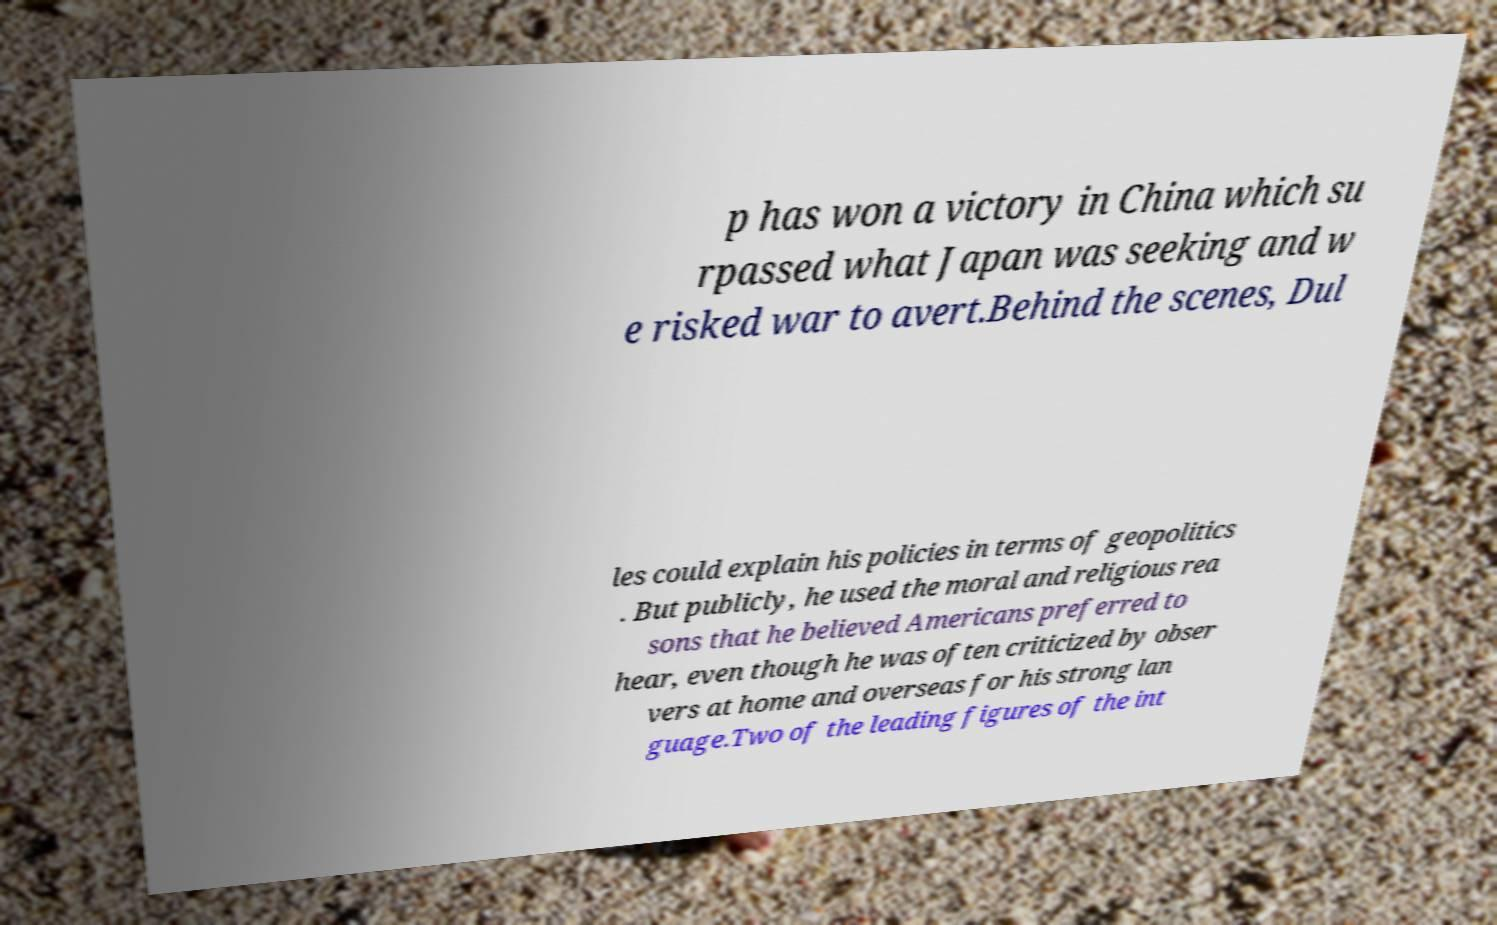I need the written content from this picture converted into text. Can you do that? p has won a victory in China which su rpassed what Japan was seeking and w e risked war to avert.Behind the scenes, Dul les could explain his policies in terms of geopolitics . But publicly, he used the moral and religious rea sons that he believed Americans preferred to hear, even though he was often criticized by obser vers at home and overseas for his strong lan guage.Two of the leading figures of the int 